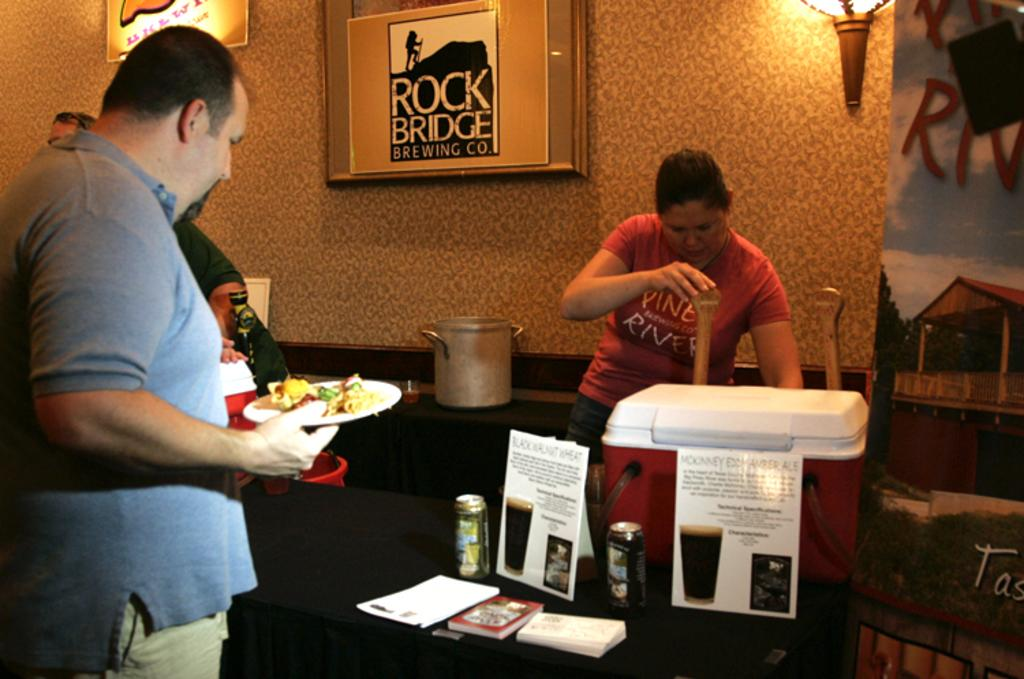<image>
Give a short and clear explanation of the subsequent image. A woman pours a beer from a tap beside a sign saying Rock Bridge Brewing Co. 